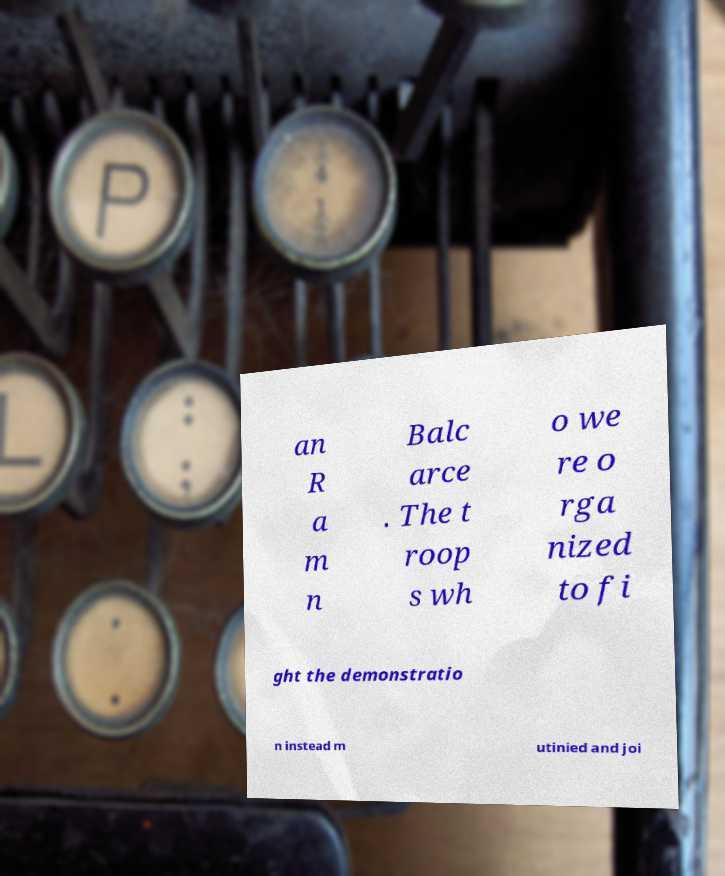What messages or text are displayed in this image? I need them in a readable, typed format. an R a m n Balc arce . The t roop s wh o we re o rga nized to fi ght the demonstratio n instead m utinied and joi 